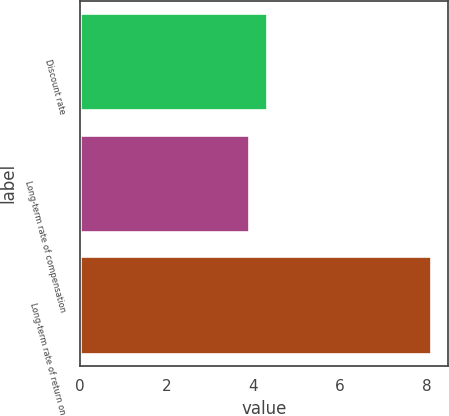Convert chart to OTSL. <chart><loc_0><loc_0><loc_500><loc_500><bar_chart><fcel>Discount rate<fcel>Long-term rate of compensation<fcel>Long-term rate of return on<nl><fcel>4.32<fcel>3.9<fcel>8.1<nl></chart> 